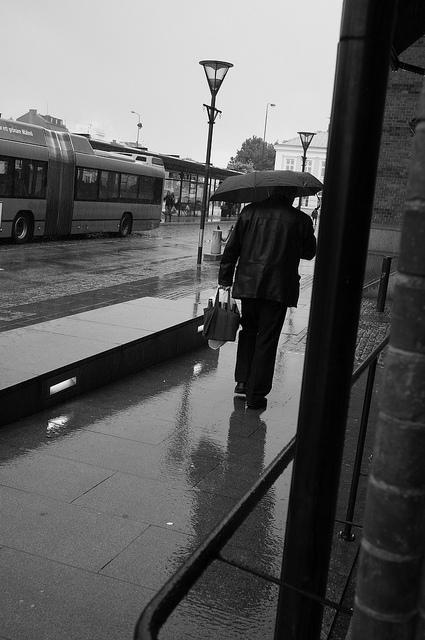How many people are in the street?
Give a very brief answer. 1. How many buses are visible?
Give a very brief answer. 1. 